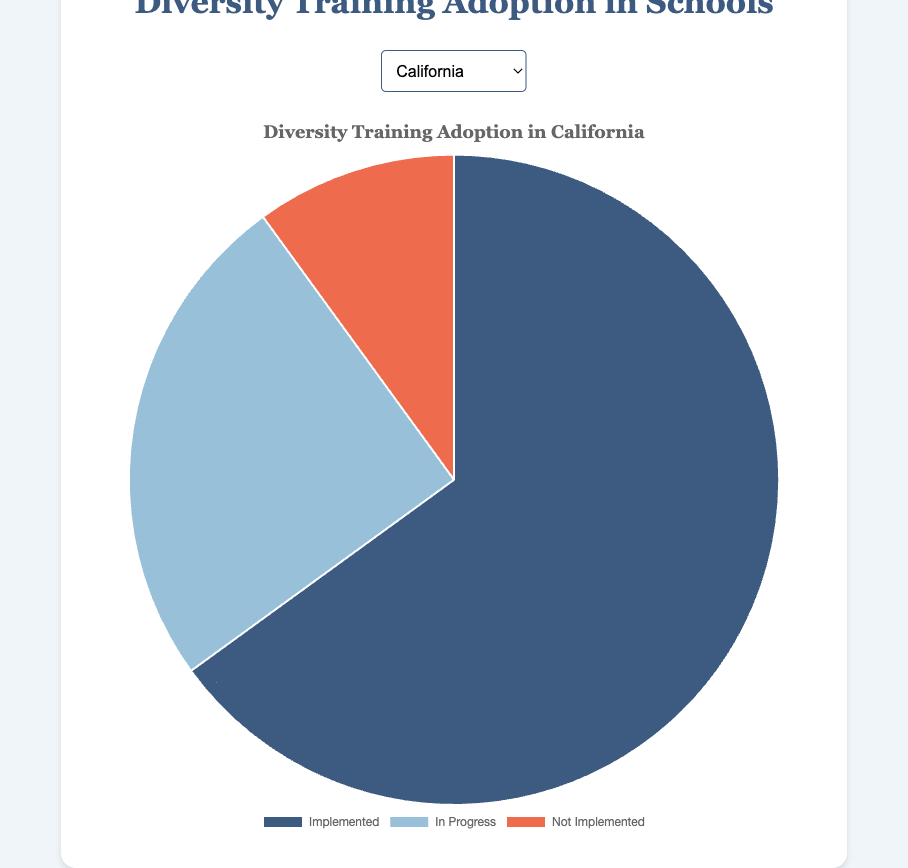How many states have more than 50% of schools with diversity training implemented? Count the states where the "Implemented" percentage exceeds 50%. California (65%), New York (55%), and Pennsylvania (55%) meet this criterion.
Answer: 3 Which state has the highest percentage of schools with diversity training not implemented? Compare the "Not Implemented" percentages across all states. Michigan has the highest percentage at 25%.
Answer: Michigan What is the total percentage of schools either implemented or in progress in Ohio? Add the "Implemented" and "In Progress" percentages for Ohio. The sum is 35% + 50% = 85%.
Answer: 85% Which state has an equal percentage of schools with diversity training in progress and not implemented? Compare the "In Progress" and "Not Implemented" percentages for each state. Florida has 40% for both categories.
Answer: Florida In which state is the percentage of schools with diversity training in progress the highest? Check the "In Progress" percentages for all states. Ohio has the highest at 50%.
Answer: Ohio What is the difference in the percentage of schools with diversity training implemented between Illinois and Georgia? Find the absolute difference in the "Implemented" percentages between Illinois (50%) and Georgia (45%). The difference is 50% - 45% = 5%.
Answer: 5% Which states have an equal percentage of schools either in progress or not implemented? Compare the sum of "In Progress" and "Not Implemented" percentages for each state. Florida and Michigan both sum up to 60% in these categories.
Answer: Florida, Michigan Which state has the lowest percentage of schools with diversity training implemented? Compare the "Implemented" percentages for all states. Ohio has the lowest at 35%.
Answer: Ohio In California, what is the ratio of schools with diversity training implemented to schools not implemented? Calculate the ratio of "Implemented" (65%) to "Not Implemented" (10%). The ratio is 65:10, which simplifies to 6.5:1.
Answer: 6.5:1 